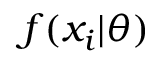Convert formula to latex. <formula><loc_0><loc_0><loc_500><loc_500>f ( x _ { i } | \theta )</formula> 